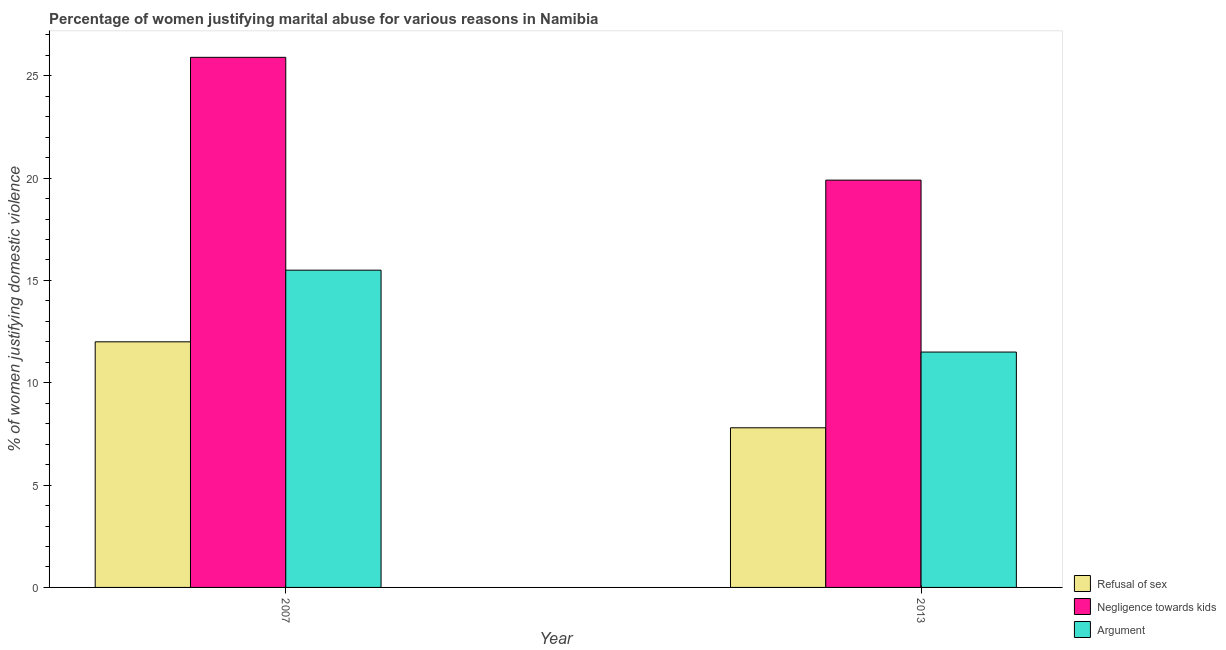How many different coloured bars are there?
Provide a short and direct response. 3. How many groups of bars are there?
Provide a short and direct response. 2. Are the number of bars on each tick of the X-axis equal?
Ensure brevity in your answer.  Yes. In how many cases, is the number of bars for a given year not equal to the number of legend labels?
Give a very brief answer. 0. What is the percentage of women justifying domestic violence due to refusal of sex in 2007?
Your answer should be compact. 12. Across all years, what is the minimum percentage of women justifying domestic violence due to arguments?
Your answer should be compact. 11.5. What is the total percentage of women justifying domestic violence due to refusal of sex in the graph?
Provide a short and direct response. 19.8. What is the difference between the percentage of women justifying domestic violence due to arguments in 2007 and that in 2013?
Ensure brevity in your answer.  4. What is the difference between the percentage of women justifying domestic violence due to refusal of sex in 2007 and the percentage of women justifying domestic violence due to arguments in 2013?
Ensure brevity in your answer.  4.2. In the year 2007, what is the difference between the percentage of women justifying domestic violence due to refusal of sex and percentage of women justifying domestic violence due to arguments?
Offer a terse response. 0. What is the ratio of the percentage of women justifying domestic violence due to refusal of sex in 2007 to that in 2013?
Ensure brevity in your answer.  1.54. Is the percentage of women justifying domestic violence due to refusal of sex in 2007 less than that in 2013?
Provide a succinct answer. No. In how many years, is the percentage of women justifying domestic violence due to arguments greater than the average percentage of women justifying domestic violence due to arguments taken over all years?
Make the answer very short. 1. What does the 1st bar from the left in 2007 represents?
Give a very brief answer. Refusal of sex. What does the 1st bar from the right in 2007 represents?
Your answer should be compact. Argument. Does the graph contain grids?
Ensure brevity in your answer.  No. Where does the legend appear in the graph?
Make the answer very short. Bottom right. What is the title of the graph?
Offer a terse response. Percentage of women justifying marital abuse for various reasons in Namibia. Does "Fuel" appear as one of the legend labels in the graph?
Provide a succinct answer. No. What is the label or title of the X-axis?
Keep it short and to the point. Year. What is the label or title of the Y-axis?
Offer a very short reply. % of women justifying domestic violence. What is the % of women justifying domestic violence in Negligence towards kids in 2007?
Ensure brevity in your answer.  25.9. What is the % of women justifying domestic violence of Argument in 2007?
Provide a succinct answer. 15.5. What is the % of women justifying domestic violence in Refusal of sex in 2013?
Provide a short and direct response. 7.8. What is the % of women justifying domestic violence in Argument in 2013?
Provide a short and direct response. 11.5. Across all years, what is the maximum % of women justifying domestic violence in Negligence towards kids?
Your answer should be very brief. 25.9. Across all years, what is the maximum % of women justifying domestic violence in Argument?
Offer a very short reply. 15.5. Across all years, what is the minimum % of women justifying domestic violence of Refusal of sex?
Make the answer very short. 7.8. Across all years, what is the minimum % of women justifying domestic violence in Argument?
Offer a terse response. 11.5. What is the total % of women justifying domestic violence in Refusal of sex in the graph?
Provide a succinct answer. 19.8. What is the total % of women justifying domestic violence in Negligence towards kids in the graph?
Ensure brevity in your answer.  45.8. What is the difference between the % of women justifying domestic violence of Refusal of sex in 2007 and the % of women justifying domestic violence of Negligence towards kids in 2013?
Your response must be concise. -7.9. What is the difference between the % of women justifying domestic violence of Negligence towards kids in 2007 and the % of women justifying domestic violence of Argument in 2013?
Ensure brevity in your answer.  14.4. What is the average % of women justifying domestic violence in Negligence towards kids per year?
Offer a very short reply. 22.9. What is the average % of women justifying domestic violence in Argument per year?
Ensure brevity in your answer.  13.5. In the year 2007, what is the difference between the % of women justifying domestic violence in Refusal of sex and % of women justifying domestic violence in Argument?
Offer a terse response. -3.5. In the year 2013, what is the difference between the % of women justifying domestic violence of Refusal of sex and % of women justifying domestic violence of Negligence towards kids?
Provide a succinct answer. -12.1. In the year 2013, what is the difference between the % of women justifying domestic violence in Negligence towards kids and % of women justifying domestic violence in Argument?
Offer a terse response. 8.4. What is the ratio of the % of women justifying domestic violence of Refusal of sex in 2007 to that in 2013?
Ensure brevity in your answer.  1.54. What is the ratio of the % of women justifying domestic violence in Negligence towards kids in 2007 to that in 2013?
Your response must be concise. 1.3. What is the ratio of the % of women justifying domestic violence in Argument in 2007 to that in 2013?
Offer a very short reply. 1.35. What is the difference between the highest and the second highest % of women justifying domestic violence in Refusal of sex?
Provide a short and direct response. 4.2. What is the difference between the highest and the second highest % of women justifying domestic violence of Negligence towards kids?
Ensure brevity in your answer.  6. What is the difference between the highest and the second highest % of women justifying domestic violence in Argument?
Give a very brief answer. 4. What is the difference between the highest and the lowest % of women justifying domestic violence in Negligence towards kids?
Your response must be concise. 6. What is the difference between the highest and the lowest % of women justifying domestic violence in Argument?
Provide a succinct answer. 4. 